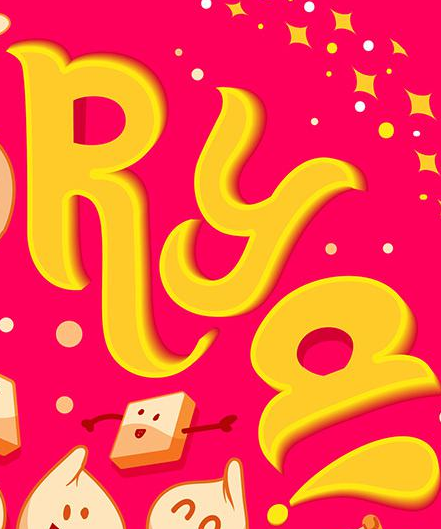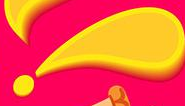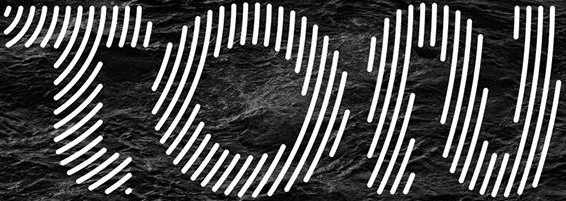What words can you see in these images in sequence, separated by a semicolon? RYa; !; TON 